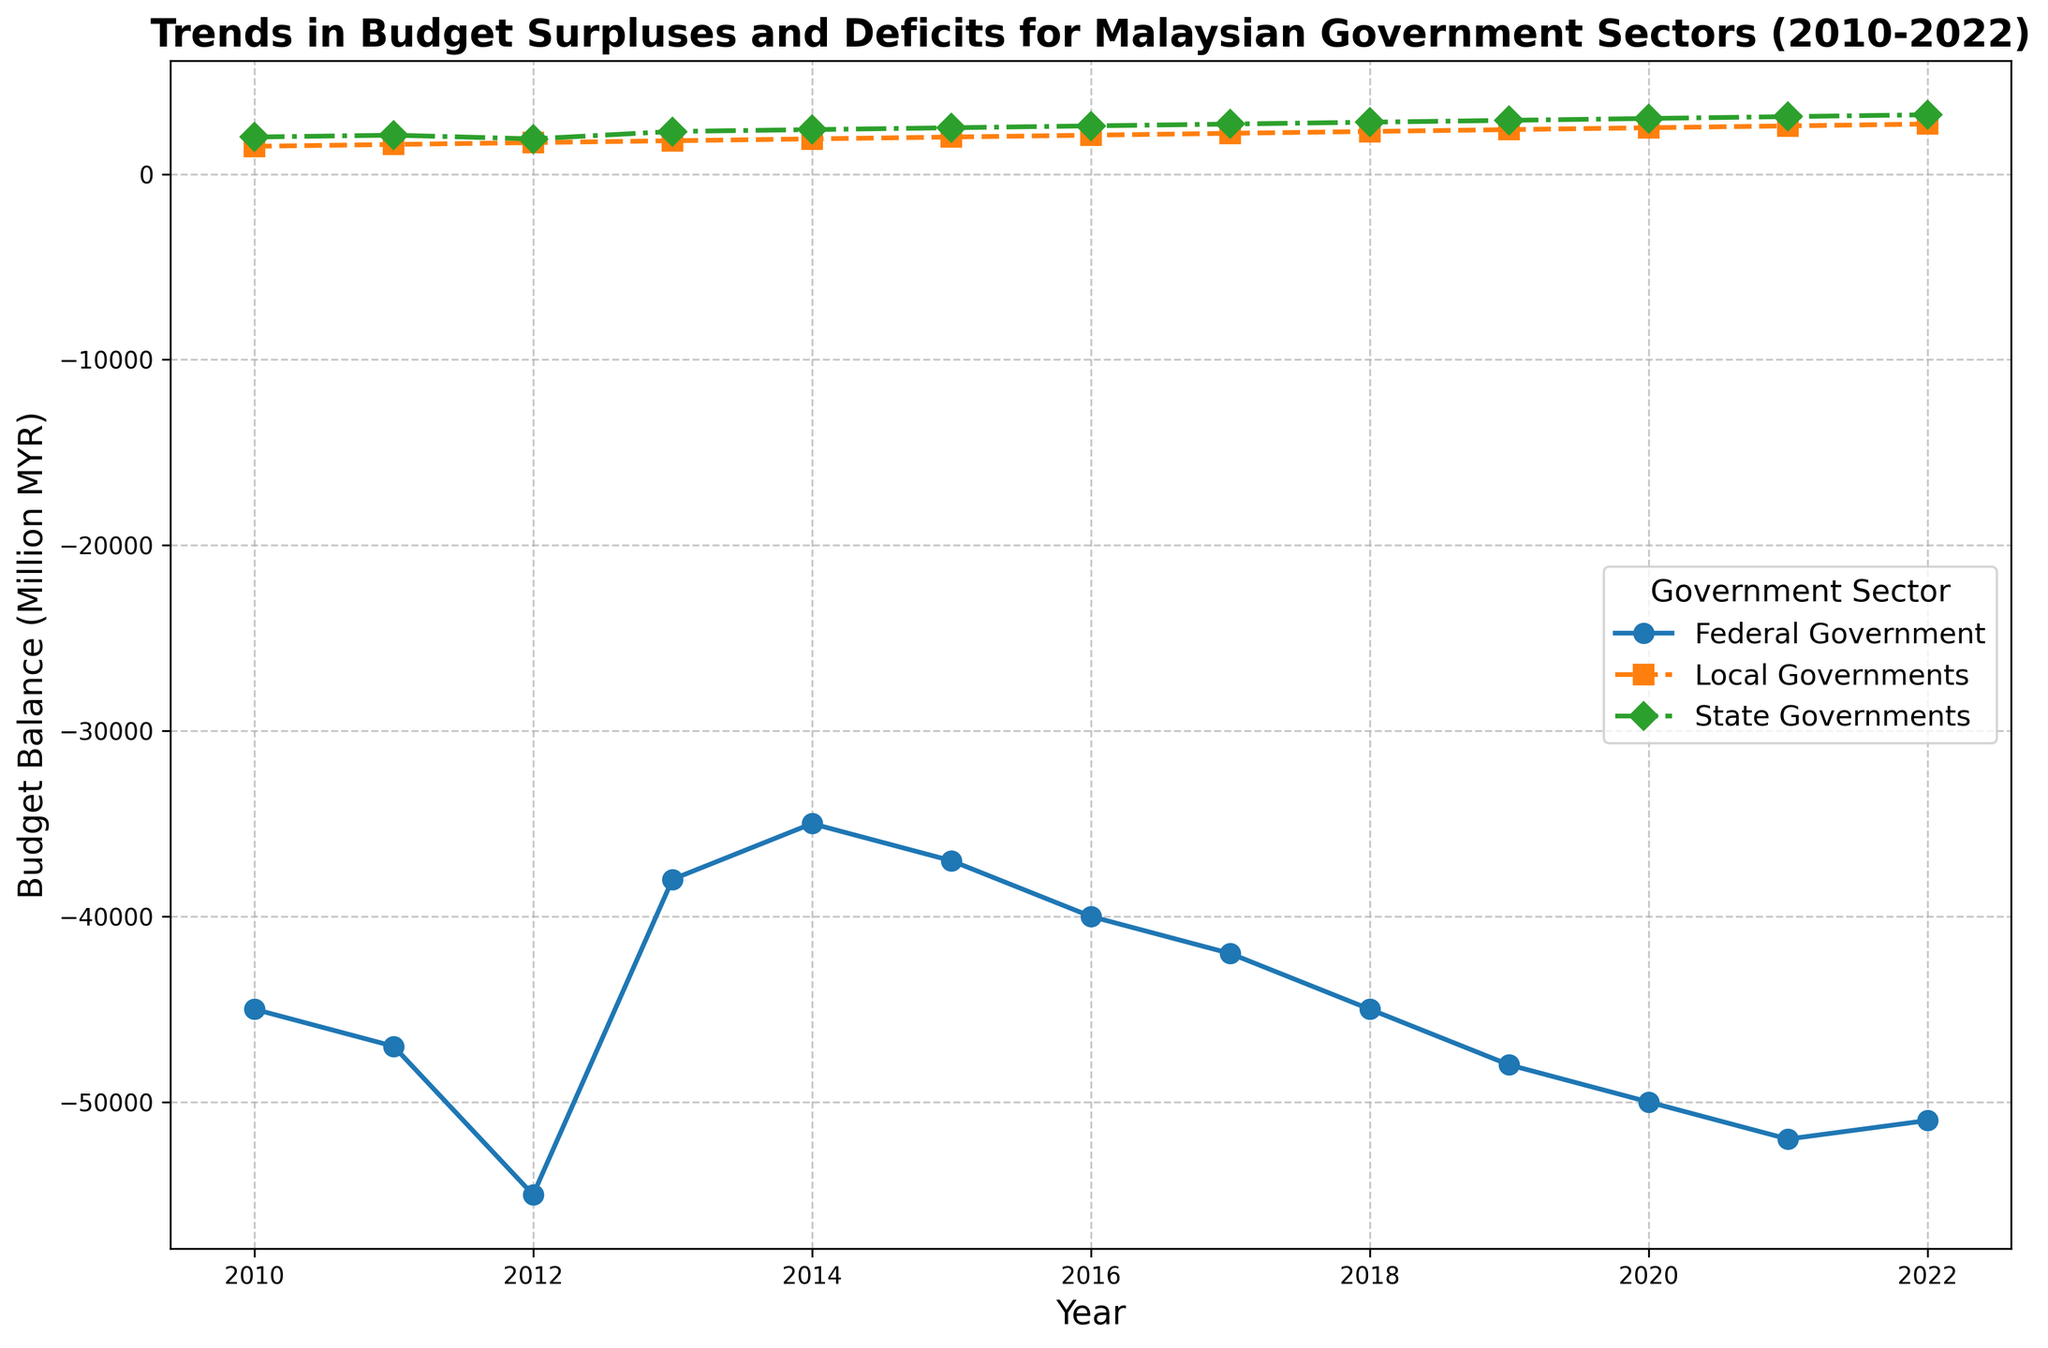Which government sector experienced the most consistent budget trend from 2010 to 2022? By examining the lines, the State Governments' line shows the most consistent upward trend without sharp fluctuations, indicating a more stable trend compared to the Federal and Local Governments.
Answer: State Governments From 2010 to 2022, which sector had the largest budget deficit? The Federal Government consistently has negative values in their budget balance, with 2021 being the largest deficit at -52,000 million MYR.
Answer: Federal Government In what year did the Local Governments have the highest budget surplus? Examining the Local Governments' line, the peak is reached in 2022 at 2,700 million MYR.
Answer: 2022 How did the Federal Government's deficit change from 2016 to 2017? The deficit increased from -40,000 million MYR in 2016 to -42,000 million MYR in 2017, indicating a worsening deficit by 2,000 million MYR.
Answer: Increased by 2,000 million MYR Did the State Governments' budget balance ever decline over the years? Reviewing the State Governments' line, there is a decline from 2,100 million MYR in 2011 to 1,900 million MYR in 2012.
Answer: Yes What's the cumulative budget balance for Local Governments from 2010 to 2022? Adding the annual budget balances from 2010 (1,500) to 2022 (2,700): 1,500 + 1,600 + 1,700 + 1,800 + 1,900 + 2,000 + 2,100 + 2,200 + 2,300 + 2,400 + 2,500 + 2,600 + 2,700 = 28,300 million MYR.
Answer: 28,300 million MYR Between 2015 and 2020, which government sector showed the most improvement in their budget balance? Between 2015 and 2020, the State Governments' budget balance increased from 2,500 million MYR to 3,000 million MYR, an improvement of 500 million MYR, which is the highest among the sectors.
Answer: State Governments How many sectors were in surplus every year from 2010 to 2022? Both State Governments and Local Governments maintained a positive budget balance throughout 2010 to 2022, resulting in two sectors always being in surplus every year.
Answer: Two In which year did the Federal Budget deficit align closely with the average deficit over the period? The Federal Budget deficits average = Sum of deficits / 13 years = (-45,000 - 47,000 - 55,000 - 38,000 - 35,000 - 37,000 - 40,000 - 42,000 - 45,000 - 48,000 - 50,000 - 52,000 - 51,000) / 13 = -46,000. The closest year is 2010 with -45,000 million MYR.
Answer: 2010 How did the State Governments' budget balance in 2012 compare to the Local Governments’ in the same year? In 2012, the State Governments had a budget balance of 1,900 million MYR, while Local Governments had a balance of 1,700 million MYR. The State Governments' budget was higher by 200 million MYR.
Answer: Higher by 200 million MYR 